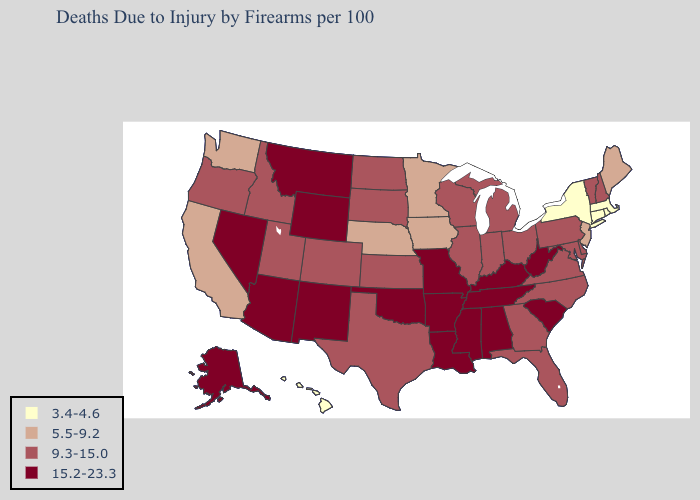What is the highest value in states that border Minnesota?
Answer briefly. 9.3-15.0. What is the lowest value in the USA?
Quick response, please. 3.4-4.6. What is the value of Georgia?
Answer briefly. 9.3-15.0. Does Virginia have a lower value than Connecticut?
Keep it brief. No. What is the value of Montana?
Concise answer only. 15.2-23.3. Name the states that have a value in the range 3.4-4.6?
Quick response, please. Connecticut, Hawaii, Massachusetts, New York, Rhode Island. Does the first symbol in the legend represent the smallest category?
Answer briefly. Yes. What is the value of North Dakota?
Answer briefly. 9.3-15.0. Does Connecticut have the lowest value in the USA?
Answer briefly. Yes. Does Indiana have a higher value than Massachusetts?
Short answer required. Yes. What is the value of West Virginia?
Be succinct. 15.2-23.3. Which states have the lowest value in the USA?
Quick response, please. Connecticut, Hawaii, Massachusetts, New York, Rhode Island. Name the states that have a value in the range 9.3-15.0?
Concise answer only. Colorado, Delaware, Florida, Georgia, Idaho, Illinois, Indiana, Kansas, Maryland, Michigan, New Hampshire, North Carolina, North Dakota, Ohio, Oregon, Pennsylvania, South Dakota, Texas, Utah, Vermont, Virginia, Wisconsin. 